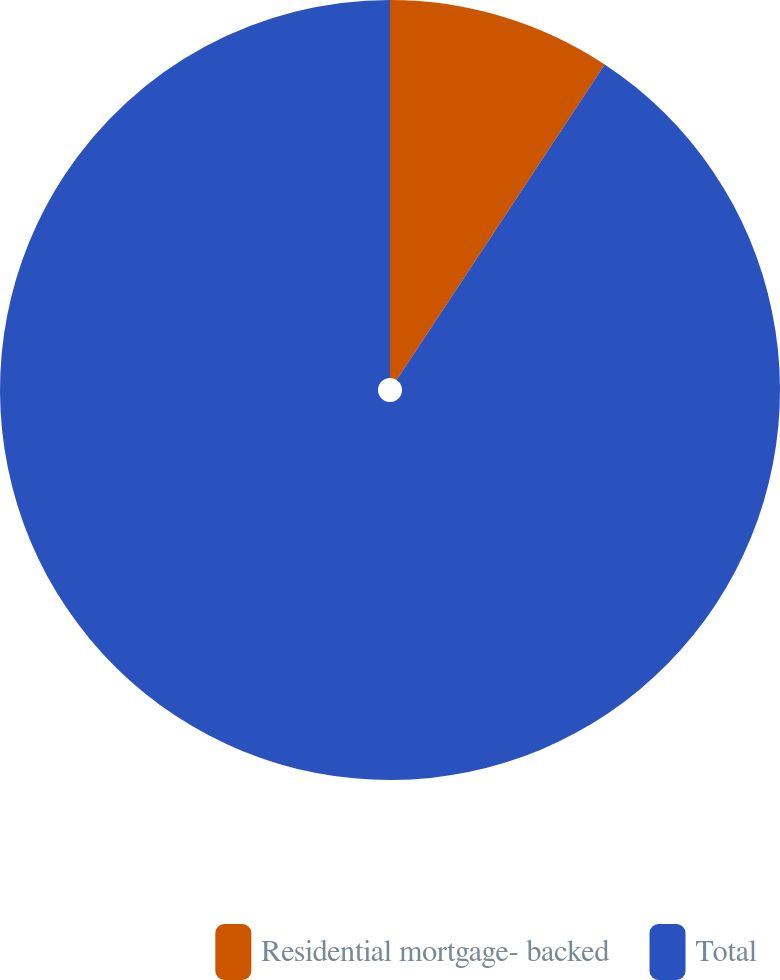Convert chart to OTSL. <chart><loc_0><loc_0><loc_500><loc_500><pie_chart><fcel>Residential mortgage- backed<fcel>Total<nl><fcel>9.28%<fcel>90.72%<nl></chart> 